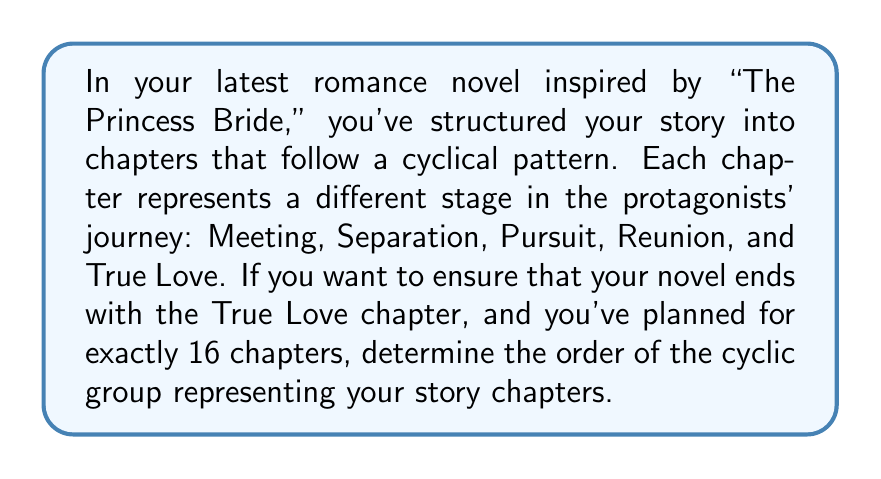Help me with this question. Let's approach this step-by-step:

1) First, we need to identify the group. In this case, we have a cyclic group with 5 elements (the 5 stages of the story). Let's call this group $G$.

2) We can represent this group as $G = \langle g \rangle$, where $g$ is the generator of the group, representing one complete cycle through all stages.

3) The order of an element in a group is the smallest positive integer $n$ such that $g^n = e$ (the identity element). In this case, it's the number of times we need to go through the cycle to get back to where we started.

4) We know that we want 16 chapters, and we want to end on "True Love". This means that 16 applications of our generator should bring us back to "True Love".

5) Mathematically, we can express this as:

   $g^{16} \equiv g^1 \pmod{5}$

   This is because "True Love" is the 1st element in our cycle (assuming we start counting at 0).

6) We can simplify this:

   $16 \equiv 1 \pmod{5}$

7) This is equivalent to saying:

   $15 \equiv 0 \pmod{5}$

8) Indeed, 15 is divisible by 5, so this holds true.

9) The order of the group is the smallest positive integer that satisfies this condition. In this case, it's 5.

Therefore, the cyclic group representing your story chapters has order 5.
Answer: The order of the cyclic group representing the story chapters is 5. 